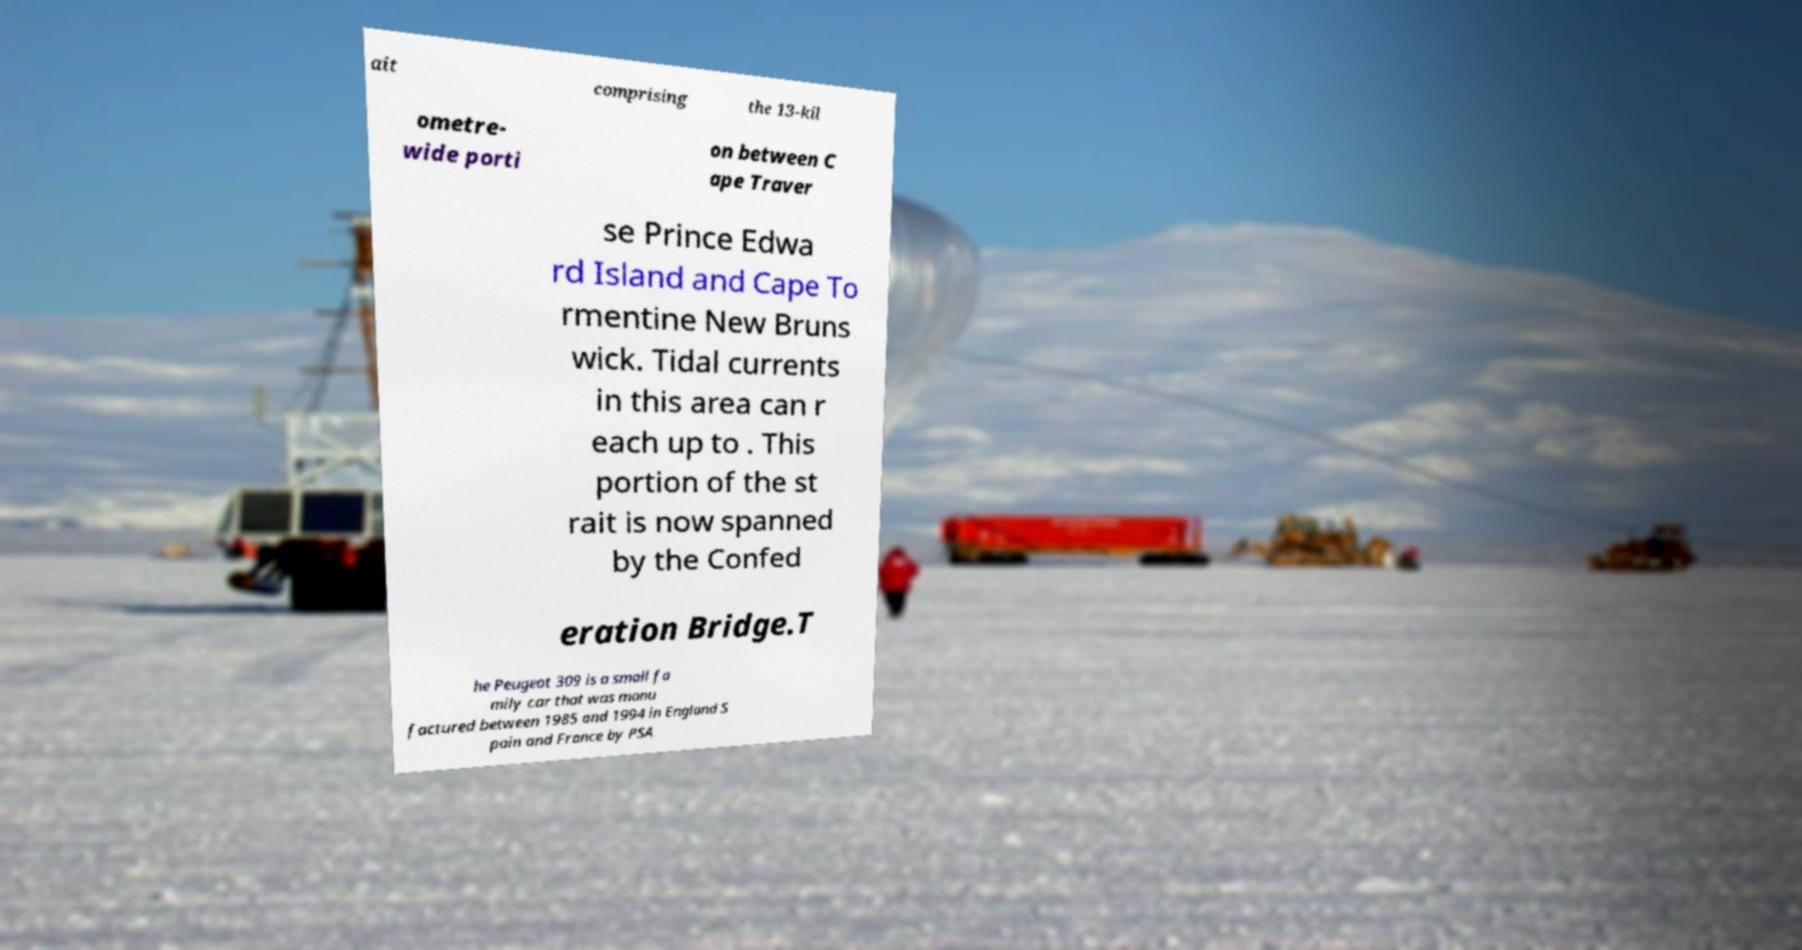Could you assist in decoding the text presented in this image and type it out clearly? ait comprising the 13-kil ometre- wide porti on between C ape Traver se Prince Edwa rd Island and Cape To rmentine New Bruns wick. Tidal currents in this area can r each up to . This portion of the st rait is now spanned by the Confed eration Bridge.T he Peugeot 309 is a small fa mily car that was manu factured between 1985 and 1994 in England S pain and France by PSA 